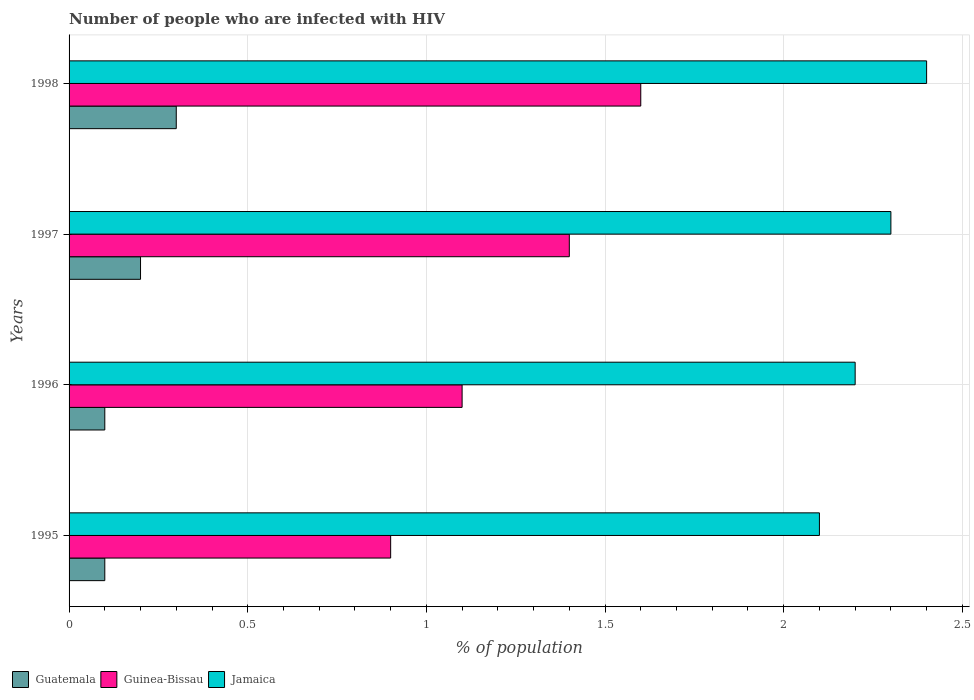How many different coloured bars are there?
Your answer should be very brief. 3. Are the number of bars on each tick of the Y-axis equal?
Your answer should be very brief. Yes. What is the percentage of HIV infected population in in Guinea-Bissau in 1996?
Your answer should be compact. 1.1. Across all years, what is the maximum percentage of HIV infected population in in Jamaica?
Offer a very short reply. 2.4. In which year was the percentage of HIV infected population in in Guinea-Bissau maximum?
Provide a succinct answer. 1998. What is the total percentage of HIV infected population in in Jamaica in the graph?
Ensure brevity in your answer.  9. What is the difference between the percentage of HIV infected population in in Guatemala in 1996 and that in 1997?
Offer a very short reply. -0.1. What is the average percentage of HIV infected population in in Guatemala per year?
Offer a terse response. 0.17. In the year 1998, what is the difference between the percentage of HIV infected population in in Guinea-Bissau and percentage of HIV infected population in in Jamaica?
Keep it short and to the point. -0.8. What is the ratio of the percentage of HIV infected population in in Guatemala in 1997 to that in 1998?
Offer a terse response. 0.67. Is the percentage of HIV infected population in in Jamaica in 1995 less than that in 1997?
Keep it short and to the point. Yes. What is the difference between the highest and the second highest percentage of HIV infected population in in Jamaica?
Provide a short and direct response. 0.1. What is the difference between the highest and the lowest percentage of HIV infected population in in Guinea-Bissau?
Your answer should be very brief. 0.7. In how many years, is the percentage of HIV infected population in in Guinea-Bissau greater than the average percentage of HIV infected population in in Guinea-Bissau taken over all years?
Your answer should be compact. 2. What does the 2nd bar from the top in 1998 represents?
Ensure brevity in your answer.  Guinea-Bissau. What does the 3rd bar from the bottom in 1996 represents?
Ensure brevity in your answer.  Jamaica. Are all the bars in the graph horizontal?
Your answer should be compact. Yes. How many years are there in the graph?
Offer a terse response. 4. What is the difference between two consecutive major ticks on the X-axis?
Make the answer very short. 0.5. Does the graph contain any zero values?
Offer a very short reply. No. Does the graph contain grids?
Provide a succinct answer. Yes. Where does the legend appear in the graph?
Give a very brief answer. Bottom left. How are the legend labels stacked?
Ensure brevity in your answer.  Horizontal. What is the title of the graph?
Offer a terse response. Number of people who are infected with HIV. What is the label or title of the X-axis?
Your response must be concise. % of population. What is the label or title of the Y-axis?
Keep it short and to the point. Years. What is the % of population in Guinea-Bissau in 1995?
Make the answer very short. 0.9. What is the % of population of Guinea-Bissau in 1996?
Provide a short and direct response. 1.1. What is the % of population of Jamaica in 1996?
Provide a succinct answer. 2.2. What is the % of population in Guatemala in 1997?
Provide a short and direct response. 0.2. What is the % of population in Guinea-Bissau in 1997?
Your answer should be very brief. 1.4. What is the % of population in Jamaica in 1997?
Offer a terse response. 2.3. What is the % of population of Jamaica in 1998?
Make the answer very short. 2.4. Across all years, what is the maximum % of population in Guatemala?
Provide a short and direct response. 0.3. Across all years, what is the maximum % of population of Guinea-Bissau?
Make the answer very short. 1.6. Across all years, what is the maximum % of population in Jamaica?
Give a very brief answer. 2.4. Across all years, what is the minimum % of population of Guinea-Bissau?
Ensure brevity in your answer.  0.9. What is the difference between the % of population of Guinea-Bissau in 1995 and that in 1996?
Make the answer very short. -0.2. What is the difference between the % of population of Jamaica in 1995 and that in 1996?
Ensure brevity in your answer.  -0.1. What is the difference between the % of population of Guinea-Bissau in 1995 and that in 1997?
Provide a short and direct response. -0.5. What is the difference between the % of population of Jamaica in 1995 and that in 1998?
Ensure brevity in your answer.  -0.3. What is the difference between the % of population of Guatemala in 1996 and that in 1997?
Give a very brief answer. -0.1. What is the difference between the % of population in Guinea-Bissau in 1996 and that in 1997?
Offer a terse response. -0.3. What is the difference between the % of population in Jamaica in 1996 and that in 1997?
Provide a succinct answer. -0.1. What is the difference between the % of population in Guatemala in 1997 and that in 1998?
Your answer should be very brief. -0.1. What is the difference between the % of population in Guinea-Bissau in 1997 and that in 1998?
Your answer should be very brief. -0.2. What is the difference between the % of population of Guinea-Bissau in 1995 and the % of population of Jamaica in 1996?
Provide a short and direct response. -1.3. What is the difference between the % of population of Guatemala in 1995 and the % of population of Guinea-Bissau in 1997?
Offer a very short reply. -1.3. What is the difference between the % of population of Guatemala in 1995 and the % of population of Jamaica in 1998?
Your answer should be compact. -2.3. What is the difference between the % of population in Guinea-Bissau in 1995 and the % of population in Jamaica in 1998?
Provide a succinct answer. -1.5. What is the difference between the % of population in Guatemala in 1996 and the % of population in Jamaica in 1997?
Provide a succinct answer. -2.2. What is the difference between the % of population of Guatemala in 1996 and the % of population of Guinea-Bissau in 1998?
Give a very brief answer. -1.5. What is the difference between the % of population in Guinea-Bissau in 1996 and the % of population in Jamaica in 1998?
Provide a short and direct response. -1.3. What is the difference between the % of population of Guinea-Bissau in 1997 and the % of population of Jamaica in 1998?
Make the answer very short. -1. What is the average % of population in Guatemala per year?
Give a very brief answer. 0.17. What is the average % of population of Guinea-Bissau per year?
Provide a short and direct response. 1.25. What is the average % of population of Jamaica per year?
Make the answer very short. 2.25. In the year 1995, what is the difference between the % of population in Guatemala and % of population in Guinea-Bissau?
Give a very brief answer. -0.8. In the year 1996, what is the difference between the % of population of Guatemala and % of population of Guinea-Bissau?
Give a very brief answer. -1. In the year 1996, what is the difference between the % of population in Guatemala and % of population in Jamaica?
Your answer should be very brief. -2.1. In the year 1997, what is the difference between the % of population in Guatemala and % of population in Jamaica?
Offer a terse response. -2.1. In the year 1997, what is the difference between the % of population of Guinea-Bissau and % of population of Jamaica?
Your answer should be compact. -0.9. What is the ratio of the % of population in Guinea-Bissau in 1995 to that in 1996?
Your response must be concise. 0.82. What is the ratio of the % of population in Jamaica in 1995 to that in 1996?
Offer a very short reply. 0.95. What is the ratio of the % of population in Guatemala in 1995 to that in 1997?
Your response must be concise. 0.5. What is the ratio of the % of population in Guinea-Bissau in 1995 to that in 1997?
Your response must be concise. 0.64. What is the ratio of the % of population in Guinea-Bissau in 1995 to that in 1998?
Keep it short and to the point. 0.56. What is the ratio of the % of population in Jamaica in 1995 to that in 1998?
Offer a terse response. 0.88. What is the ratio of the % of population in Guatemala in 1996 to that in 1997?
Provide a succinct answer. 0.5. What is the ratio of the % of population of Guinea-Bissau in 1996 to that in 1997?
Provide a succinct answer. 0.79. What is the ratio of the % of population of Jamaica in 1996 to that in 1997?
Offer a very short reply. 0.96. What is the ratio of the % of population in Guinea-Bissau in 1996 to that in 1998?
Give a very brief answer. 0.69. What is the ratio of the % of population in Jamaica in 1996 to that in 1998?
Your response must be concise. 0.92. What is the difference between the highest and the second highest % of population of Guatemala?
Your answer should be compact. 0.1. What is the difference between the highest and the second highest % of population in Jamaica?
Your response must be concise. 0.1. What is the difference between the highest and the lowest % of population in Guatemala?
Your answer should be compact. 0.2. What is the difference between the highest and the lowest % of population of Jamaica?
Make the answer very short. 0.3. 